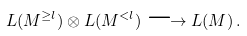<formula> <loc_0><loc_0><loc_500><loc_500>L ( M ^ { \geq l } ) \otimes L ( M ^ { < l } ) \longrightarrow L ( M ) \, .</formula> 